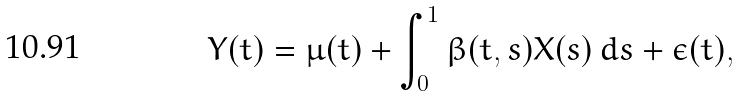<formula> <loc_0><loc_0><loc_500><loc_500>Y ( t ) = \mu ( t ) + \int _ { 0 } ^ { 1 } \beta ( t , s ) X ( s ) \, d s + \epsilon ( t ) ,</formula> 